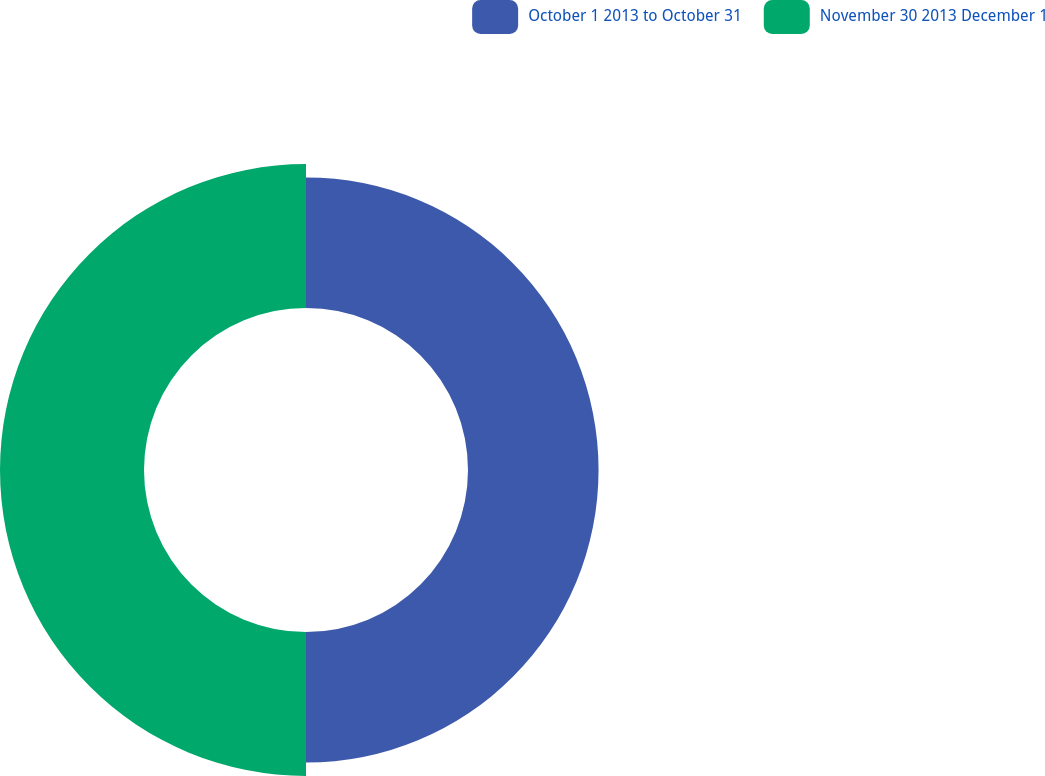<chart> <loc_0><loc_0><loc_500><loc_500><pie_chart><fcel>October 1 2013 to October 31<fcel>November 30 2013 December 1<nl><fcel>47.55%<fcel>52.45%<nl></chart> 